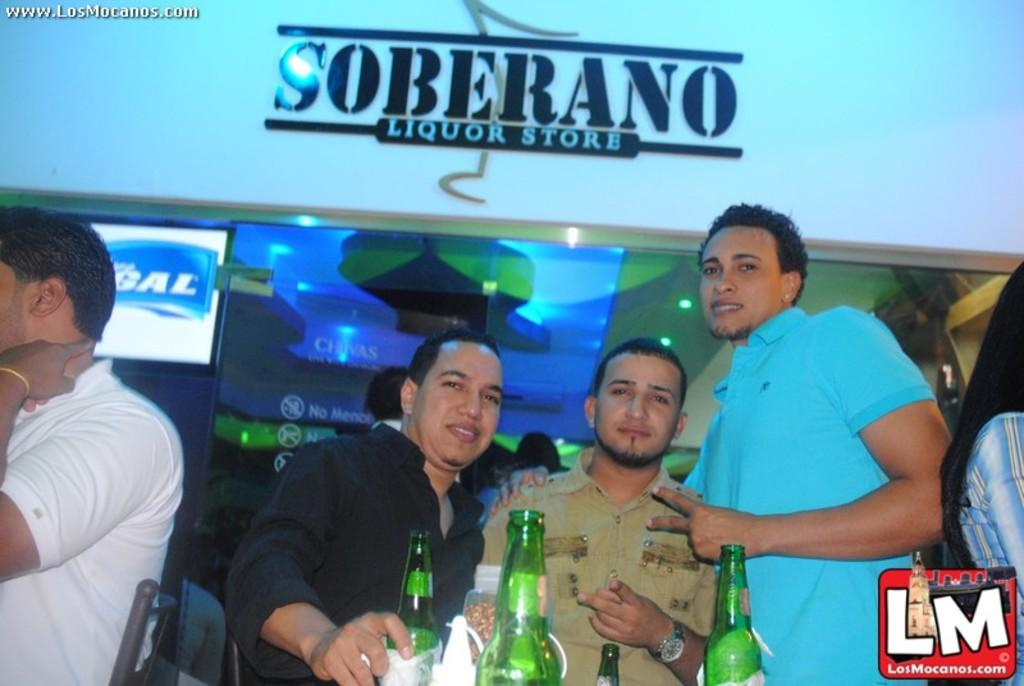<image>
Provide a brief description of the given image. Three people stood outside a Soberano liquor store. 